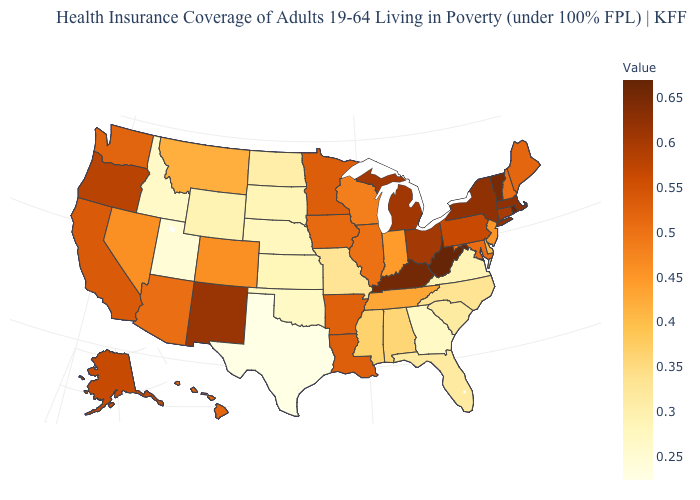Does Idaho have the highest value in the USA?
Write a very short answer. No. Is the legend a continuous bar?
Quick response, please. Yes. Among the states that border Illinois , which have the lowest value?
Keep it brief. Missouri. Among the states that border Rhode Island , which have the lowest value?
Give a very brief answer. Connecticut. Among the states that border Kansas , which have the highest value?
Concise answer only. Colorado. 